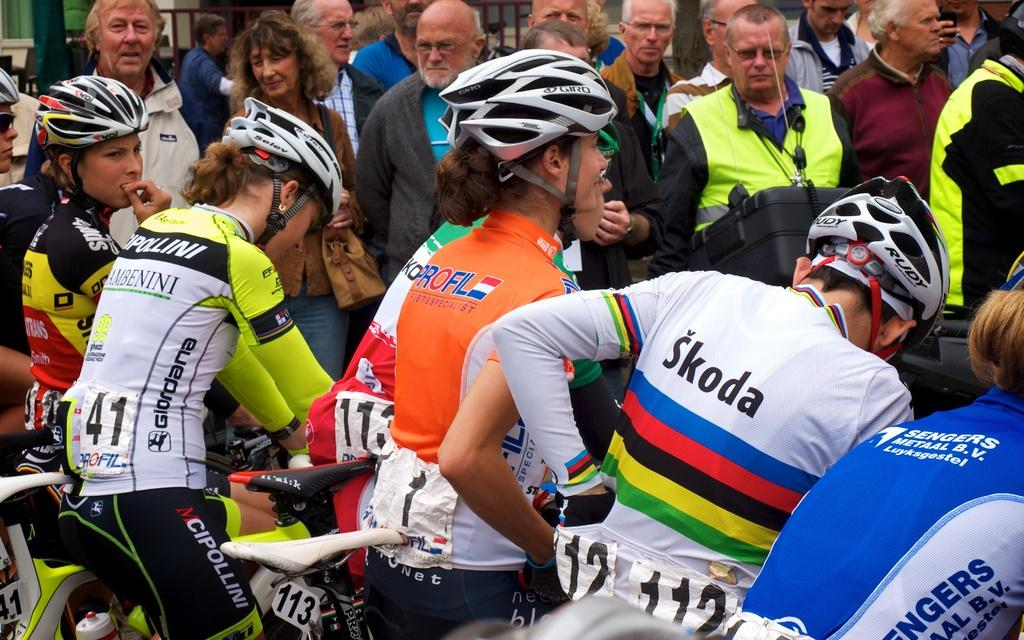What are the people doing in the image? The people are sitting on a bicycle in the image. What safety precaution are the people taking while riding the bicycle? The people are wearing helmets. Are there any other people visible in the image? Yes, there are other people standing behind the bicycle in the image. What type of houses can be seen in the background of the image? There are no houses visible in the image; it only features people sitting on a bicycle and other people standing behind it. Can you describe the stew that is being cooked in the image? There is no stew present in the image. 